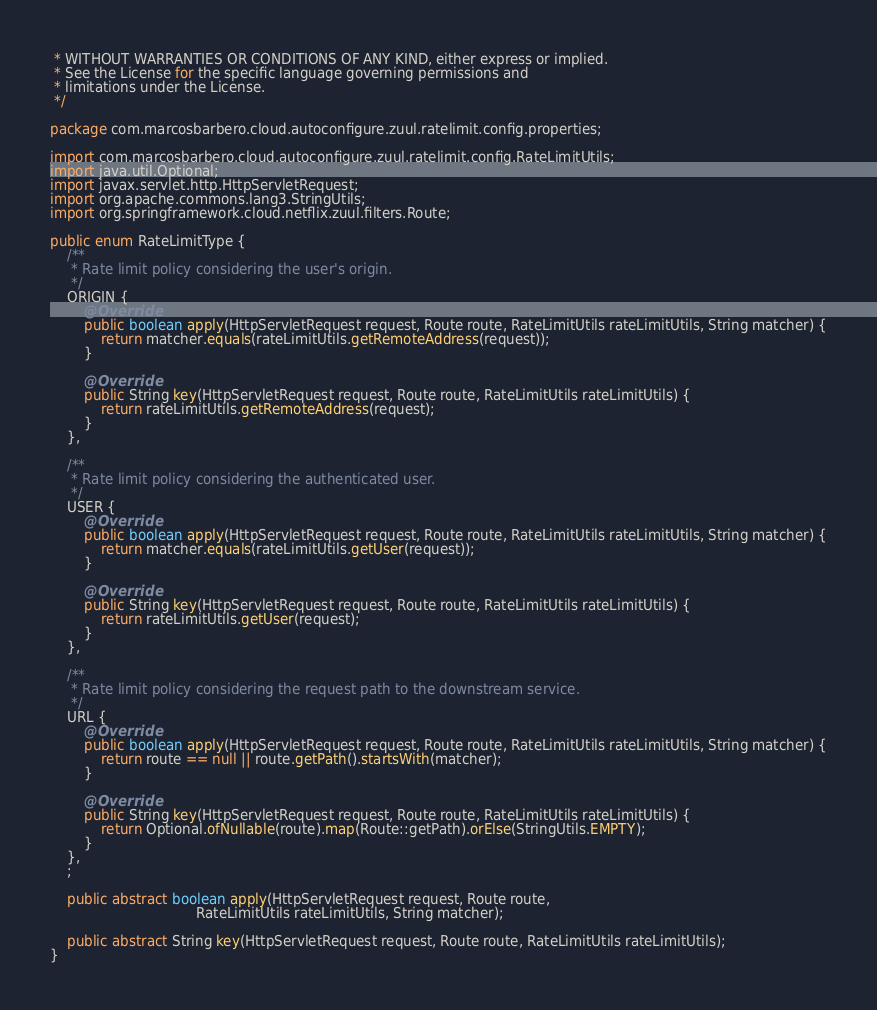<code> <loc_0><loc_0><loc_500><loc_500><_Java_> * WITHOUT WARRANTIES OR CONDITIONS OF ANY KIND, either express or implied.
 * See the License for the specific language governing permissions and
 * limitations under the License.
 */

package com.marcosbarbero.cloud.autoconfigure.zuul.ratelimit.config.properties;

import com.marcosbarbero.cloud.autoconfigure.zuul.ratelimit.config.RateLimitUtils;
import java.util.Optional;
import javax.servlet.http.HttpServletRequest;
import org.apache.commons.lang3.StringUtils;
import org.springframework.cloud.netflix.zuul.filters.Route;

public enum RateLimitType {
    /**
     * Rate limit policy considering the user's origin.
     */
    ORIGIN {
        @Override
        public boolean apply(HttpServletRequest request, Route route, RateLimitUtils rateLimitUtils, String matcher) {
            return matcher.equals(rateLimitUtils.getRemoteAddress(request));
        }

        @Override
        public String key(HttpServletRequest request, Route route, RateLimitUtils rateLimitUtils) {
            return rateLimitUtils.getRemoteAddress(request);
        }
    },

    /**
     * Rate limit policy considering the authenticated user.
     */
    USER {
        @Override
        public boolean apply(HttpServletRequest request, Route route, RateLimitUtils rateLimitUtils, String matcher) {
            return matcher.equals(rateLimitUtils.getUser(request));
        }

        @Override
        public String key(HttpServletRequest request, Route route, RateLimitUtils rateLimitUtils) {
            return rateLimitUtils.getUser(request);
        }
    },

    /**
     * Rate limit policy considering the request path to the downstream service.
     */
    URL {
        @Override
        public boolean apply(HttpServletRequest request, Route route, RateLimitUtils rateLimitUtils, String matcher) {
            return route == null || route.getPath().startsWith(matcher);
        }

        @Override
        public String key(HttpServletRequest request, Route route, RateLimitUtils rateLimitUtils) {
            return Optional.ofNullable(route).map(Route::getPath).orElse(StringUtils.EMPTY);
        }
    },
    ;

    public abstract boolean apply(HttpServletRequest request, Route route,
                                  RateLimitUtils rateLimitUtils, String matcher);

    public abstract String key(HttpServletRequest request, Route route, RateLimitUtils rateLimitUtils);
}
</code> 